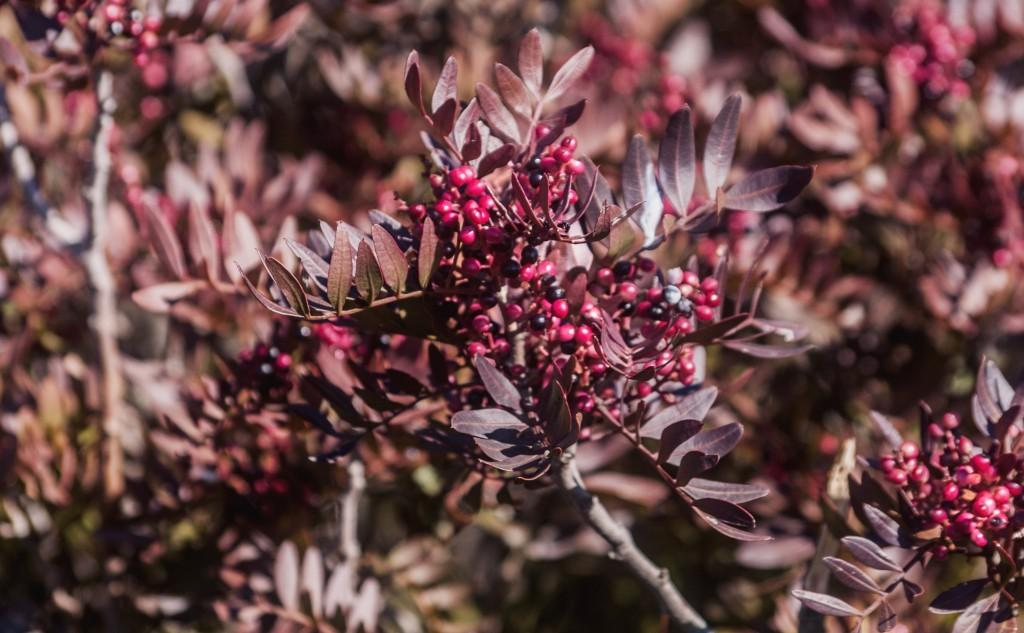What is located in the foreground of the image? There are fruits and plants in the foreground of the image. Can you describe the plants in the foreground? The plants in the foreground are not specified, but they are present alongside the fruits. What else can be seen in the background of the image? There are plants in the background of the image. What type of brick is being used to teach the plants in the image? There is no brick or teaching activity present in the image; it features fruits and plants in the foreground and background. Can you describe the kiss between the fruits and plants in the image? There is no kiss between the fruits and plants in the image; it simply shows them in their natural state. 